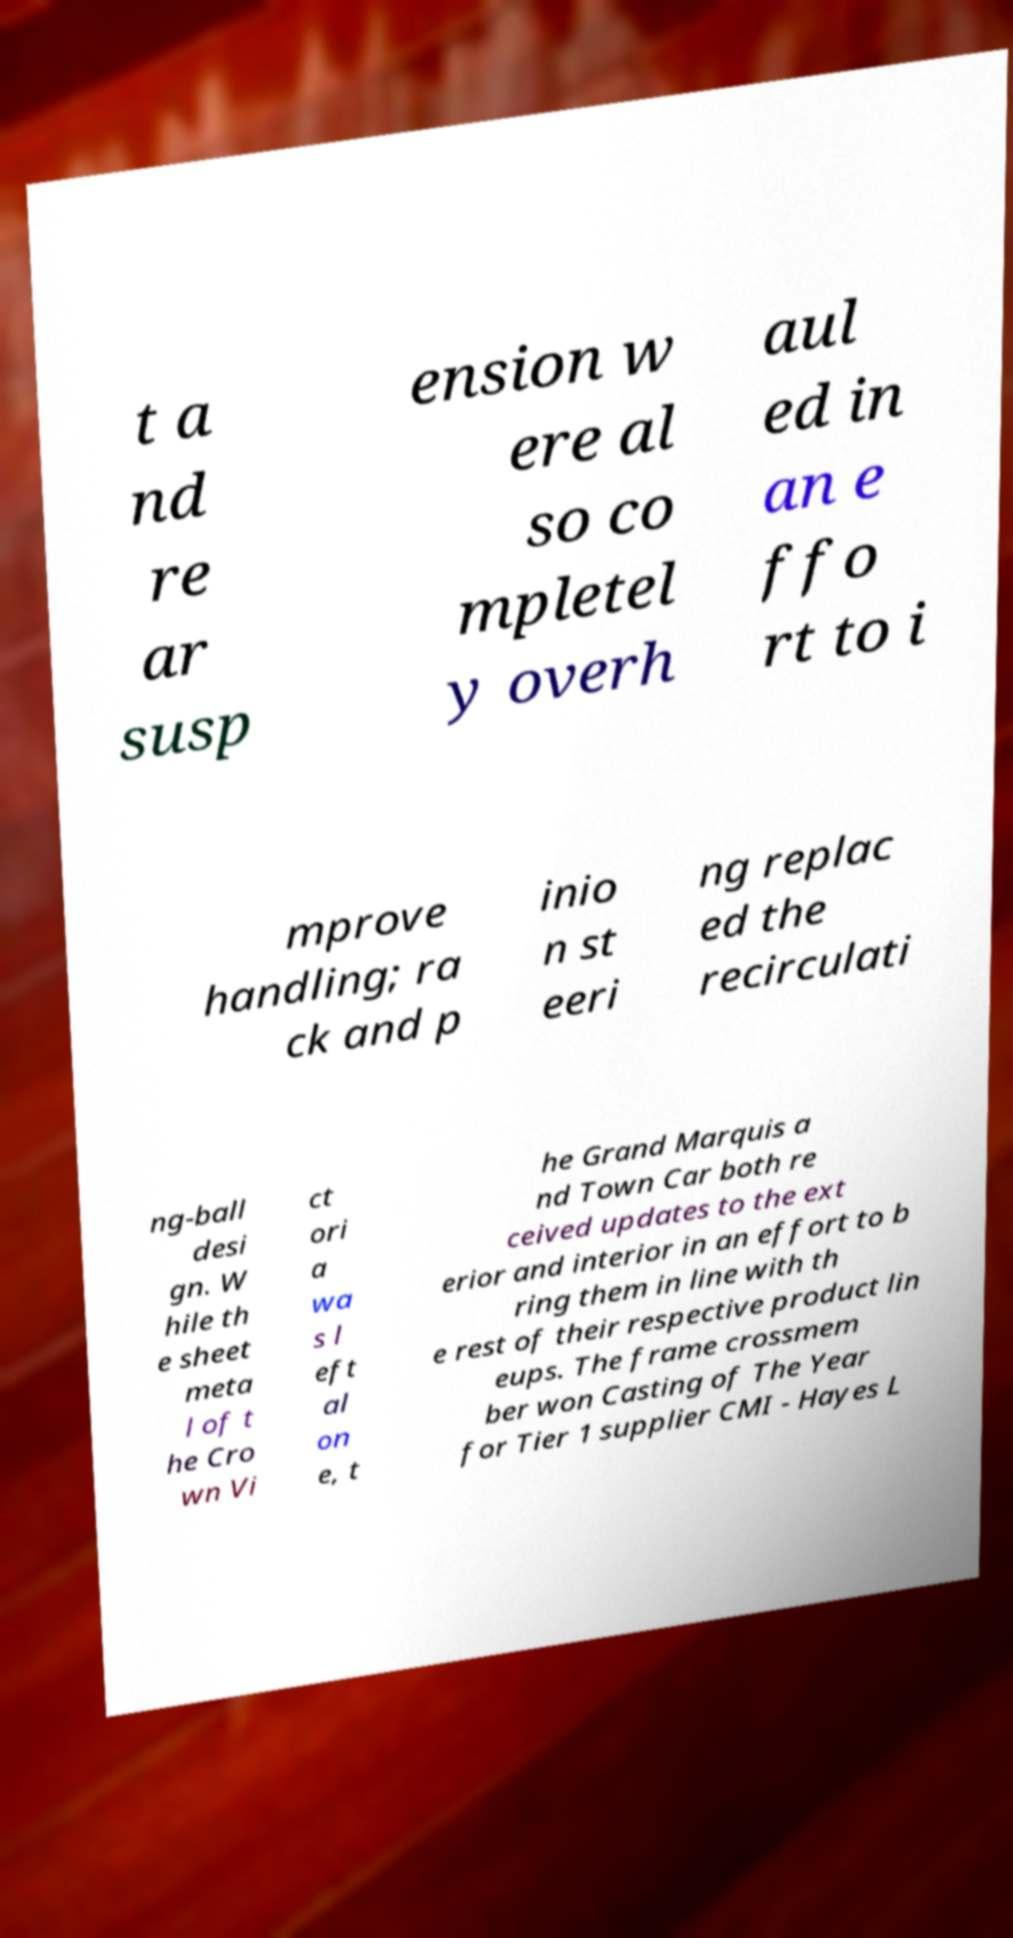For documentation purposes, I need the text within this image transcribed. Could you provide that? t a nd re ar susp ension w ere al so co mpletel y overh aul ed in an e ffo rt to i mprove handling; ra ck and p inio n st eeri ng replac ed the recirculati ng-ball desi gn. W hile th e sheet meta l of t he Cro wn Vi ct ori a wa s l eft al on e, t he Grand Marquis a nd Town Car both re ceived updates to the ext erior and interior in an effort to b ring them in line with th e rest of their respective product lin eups. The frame crossmem ber won Casting of The Year for Tier 1 supplier CMI - Hayes L 